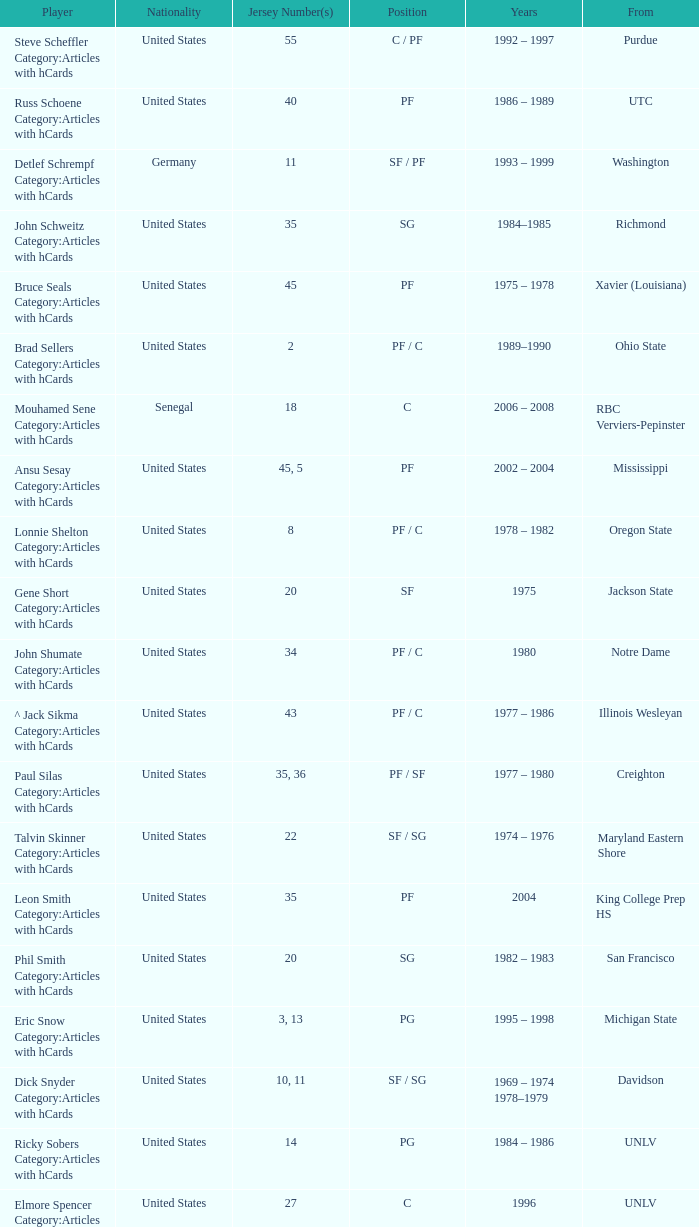Who puts on the jersey number 20 and assumes the spot of sg? Phil Smith Category:Articles with hCards, Jon Sundvold Category:Articles with hCards. 